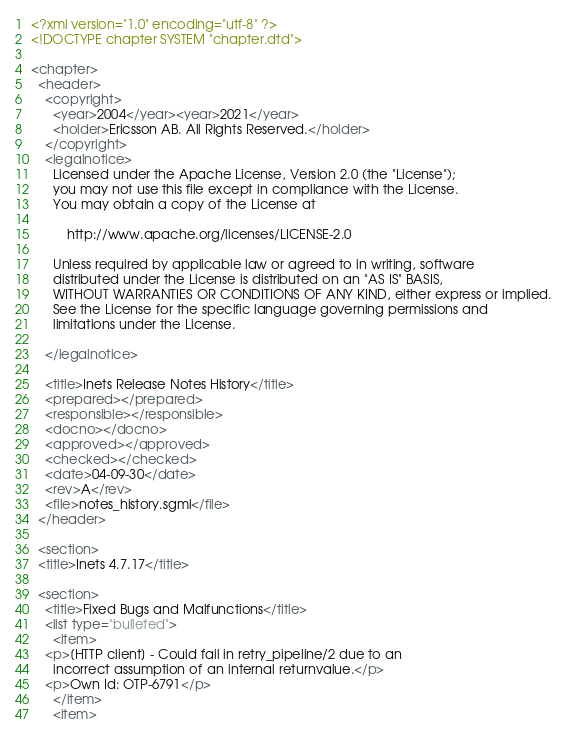<code> <loc_0><loc_0><loc_500><loc_500><_XML_><?xml version="1.0" encoding="utf-8" ?>
<!DOCTYPE chapter SYSTEM "chapter.dtd">

<chapter>
  <header>
    <copyright>
      <year>2004</year><year>2021</year>
      <holder>Ericsson AB. All Rights Reserved.</holder>
    </copyright>
    <legalnotice>
      Licensed under the Apache License, Version 2.0 (the "License");
      you may not use this file except in compliance with the License.
      You may obtain a copy of the License at
 
          http://www.apache.org/licenses/LICENSE-2.0

      Unless required by applicable law or agreed to in writing, software
      distributed under the License is distributed on an "AS IS" BASIS,
      WITHOUT WARRANTIES OR CONDITIONS OF ANY KIND, either express or implied.
      See the License for the specific language governing permissions and
      limitations under the License.

    </legalnotice>

    <title>Inets Release Notes History</title>
    <prepared></prepared>
    <responsible></responsible>
    <docno></docno>
    <approved></approved>
    <checked></checked>
    <date>04-09-30</date>
    <rev>A</rev>
    <file>notes_history.sgml</file>
  </header>
  
  <section>
  <title>Inets 4.7.17</title>
  
  <section>
    <title>Fixed Bugs and Malfunctions</title>
    <list type="bulleted">
      <item>
	<p>[HTTP client] - Could fail in retry_pipeline/2 due to an
	  incorrect assumption of an internal returnvalue.</p>
	<p>Own Id: OTP-6791</p>
      </item>
      <item></code> 